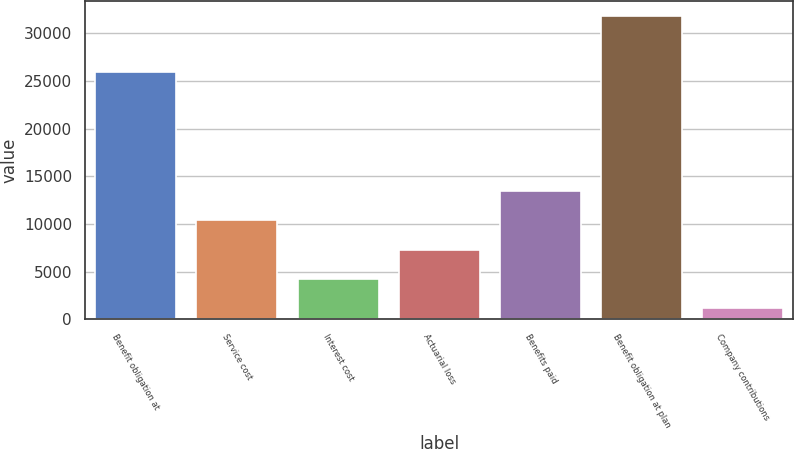Convert chart. <chart><loc_0><loc_0><loc_500><loc_500><bar_chart><fcel>Benefit obligation at<fcel>Service cost<fcel>Interest cost<fcel>Actuarial loss<fcel>Benefits paid<fcel>Benefit obligation at plan<fcel>Company contributions<nl><fcel>25937<fcel>10376.2<fcel>4253.4<fcel>7314.8<fcel>13437.6<fcel>31806<fcel>1192<nl></chart> 